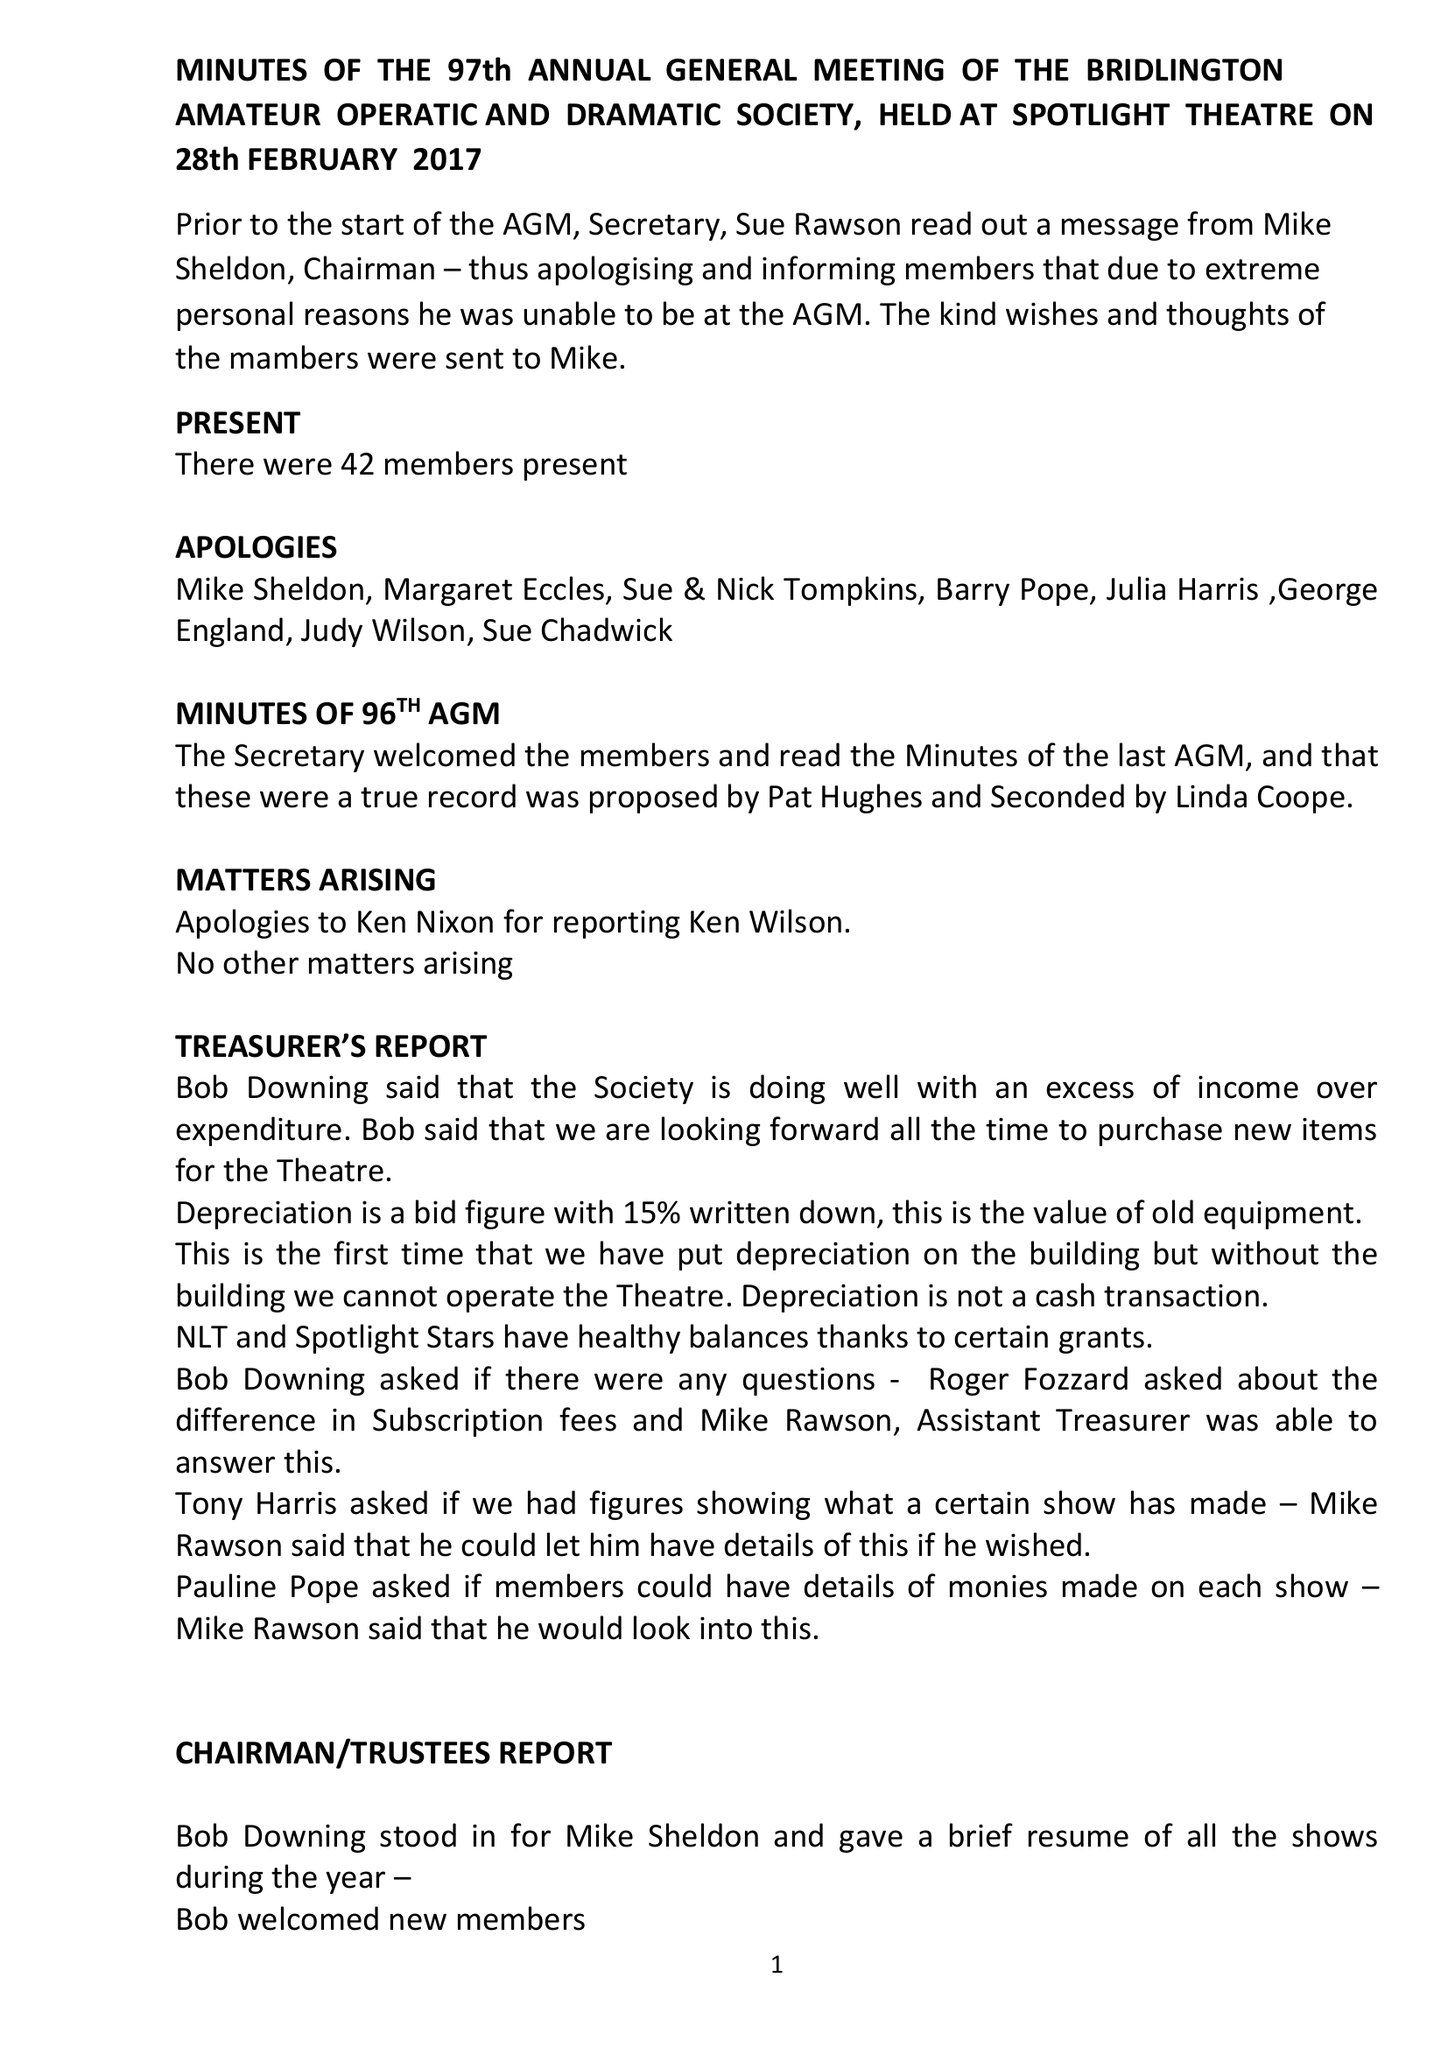What is the value for the income_annually_in_british_pounds?
Answer the question using a single word or phrase. 81178.00 